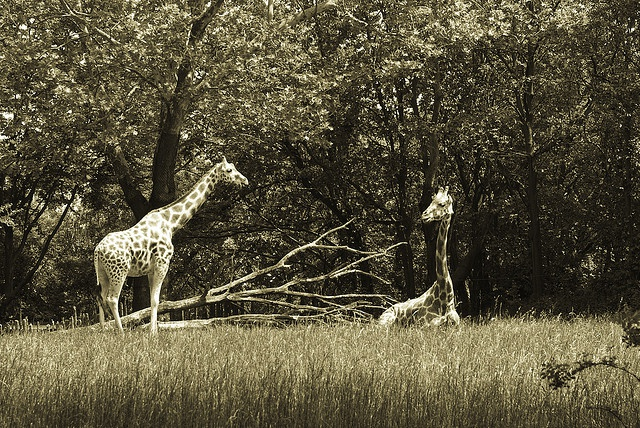Describe the objects in this image and their specific colors. I can see giraffe in black, ivory, tan, and beige tones and giraffe in black, ivory, darkgreen, and tan tones in this image. 